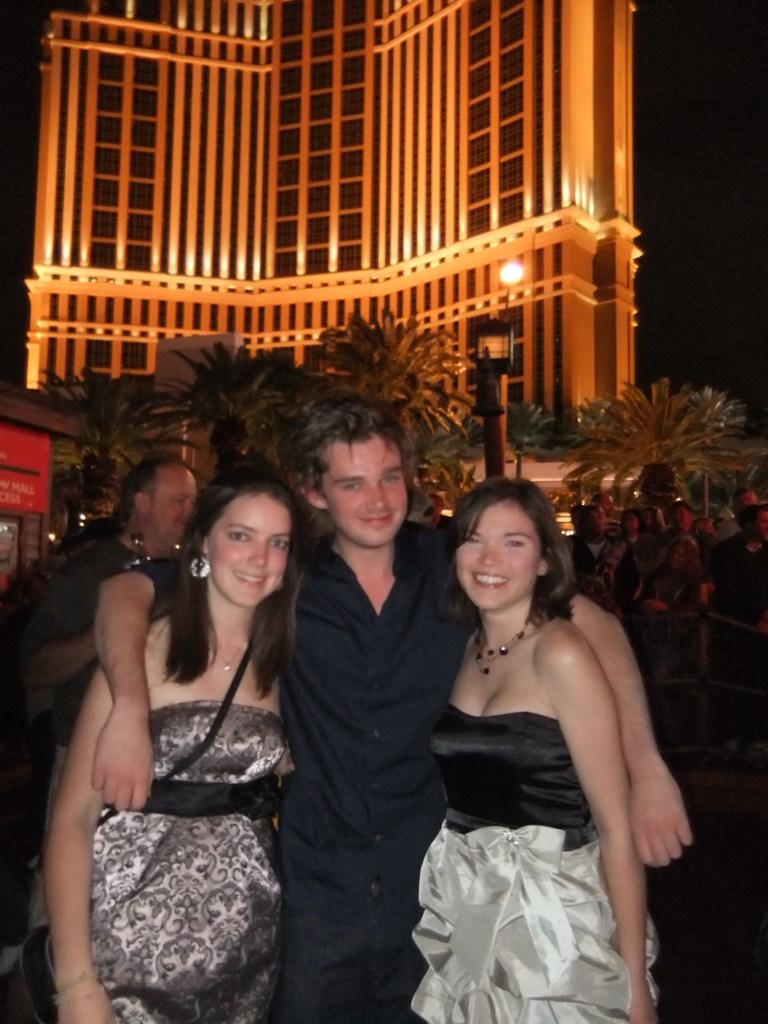How many people are standing in the image? There are three persons standing and smiling in the image. Can you describe the group of people in the image? There is a group of people standing in the image. What can be seen in the background of the image? There are trees, a building, and the sky visible in the background of the image. Can you see any kittens playing in the ocean in the image? There are no kittens or ocean present in the image. What type of work are the people doing in the image? The image does not show any work being done; it simply depicts a group of people standing and smiling. 